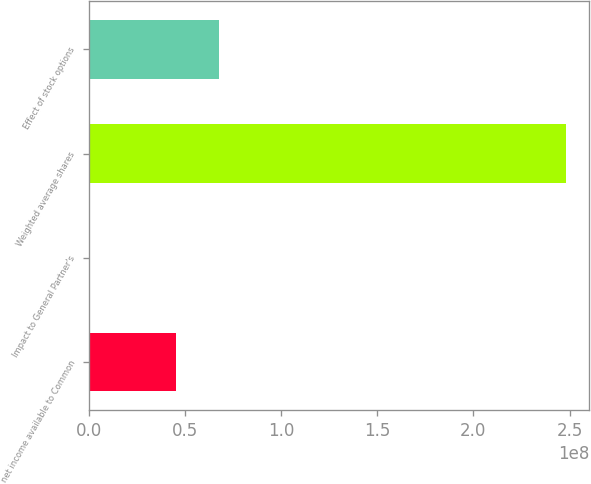Convert chart. <chart><loc_0><loc_0><loc_500><loc_500><bar_chart><fcel>net income available to Common<fcel>Impact to General Partner's<fcel>Weighted average shares<fcel>Effect of stock options<nl><fcel>4.51769e+07<fcel>209<fcel>2.47921e+08<fcel>6.77652e+07<nl></chart> 